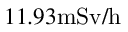Convert formula to latex. <formula><loc_0><loc_0><loc_500><loc_500>1 1 . 9 3 m S v / h</formula> 